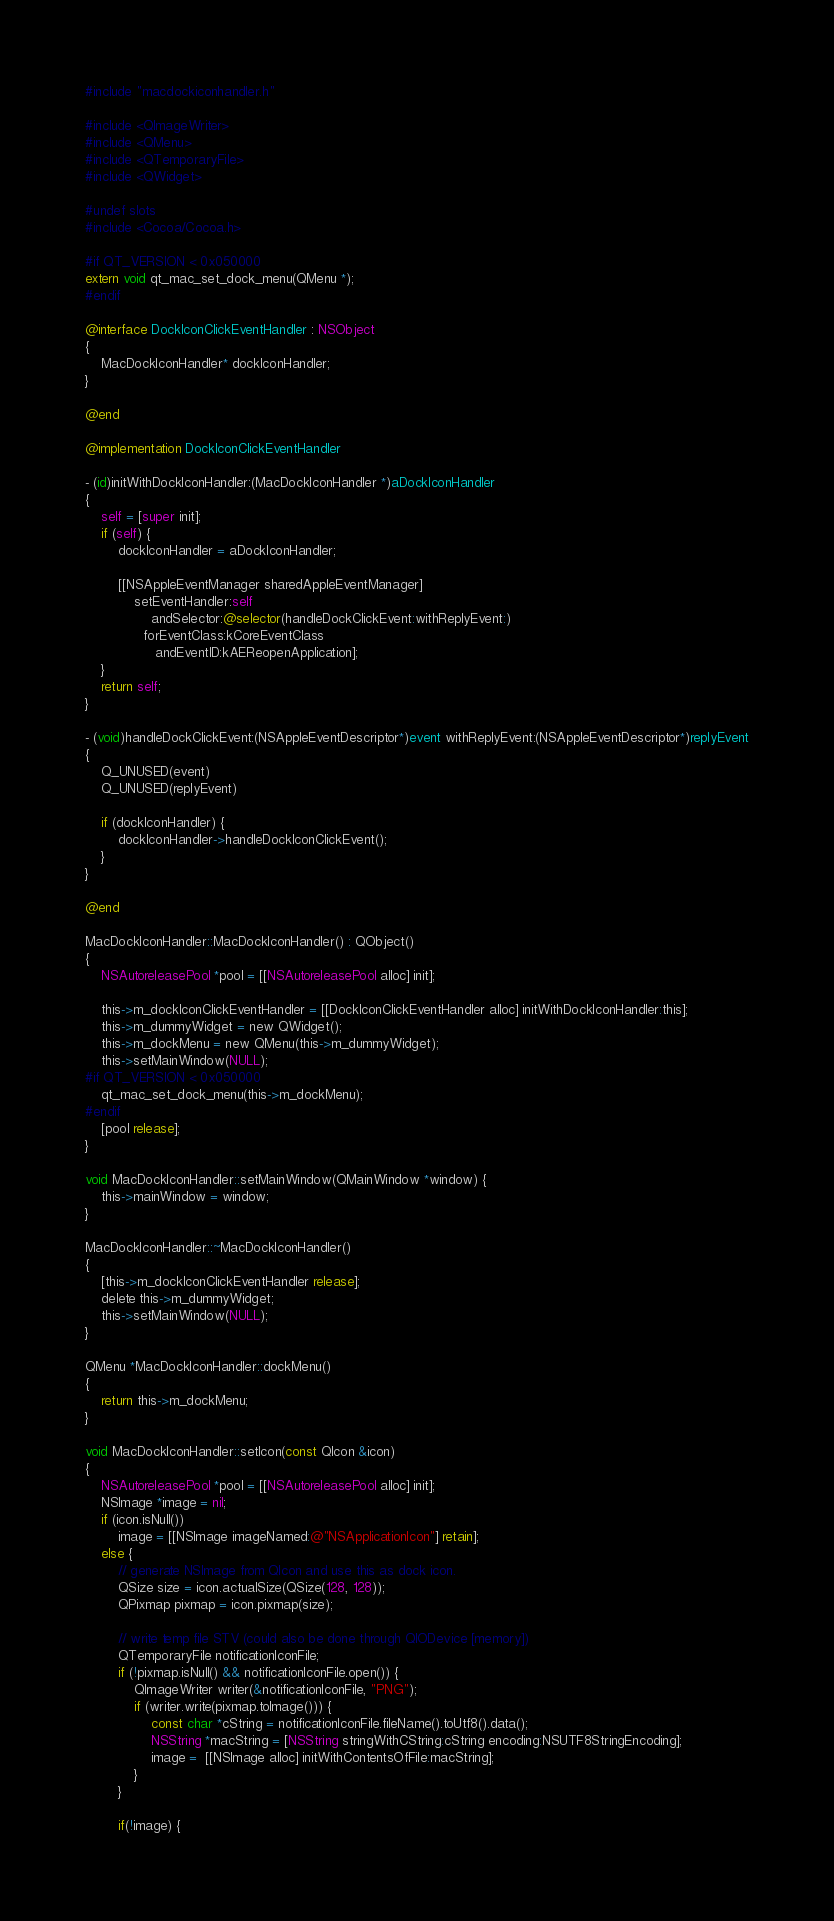Convert code to text. <code><loc_0><loc_0><loc_500><loc_500><_ObjectiveC_>#include "macdockiconhandler.h"

#include <QImageWriter>
#include <QMenu>
#include <QTemporaryFile>
#include <QWidget>

#undef slots
#include <Cocoa/Cocoa.h>

#if QT_VERSION < 0x050000
extern void qt_mac_set_dock_menu(QMenu *);
#endif

@interface DockIconClickEventHandler : NSObject
{
    MacDockIconHandler* dockIconHandler;
}

@end

@implementation DockIconClickEventHandler

- (id)initWithDockIconHandler:(MacDockIconHandler *)aDockIconHandler
{
    self = [super init];
    if (self) {
        dockIconHandler = aDockIconHandler;

        [[NSAppleEventManager sharedAppleEventManager]
            setEventHandler:self
                andSelector:@selector(handleDockClickEvent:withReplyEvent:)
              forEventClass:kCoreEventClass
                 andEventID:kAEReopenApplication];
    }
    return self;
}

- (void)handleDockClickEvent:(NSAppleEventDescriptor*)event withReplyEvent:(NSAppleEventDescriptor*)replyEvent
{
    Q_UNUSED(event)
    Q_UNUSED(replyEvent)

    if (dockIconHandler) {
        dockIconHandler->handleDockIconClickEvent();
    }
}

@end

MacDockIconHandler::MacDockIconHandler() : QObject()
{
    NSAutoreleasePool *pool = [[NSAutoreleasePool alloc] init];

    this->m_dockIconClickEventHandler = [[DockIconClickEventHandler alloc] initWithDockIconHandler:this];
    this->m_dummyWidget = new QWidget();
    this->m_dockMenu = new QMenu(this->m_dummyWidget);
    this->setMainWindow(NULL);
#if QT_VERSION < 0x050000
    qt_mac_set_dock_menu(this->m_dockMenu);
#endif
    [pool release];
}

void MacDockIconHandler::setMainWindow(QMainWindow *window) {
    this->mainWindow = window;
}

MacDockIconHandler::~MacDockIconHandler()
{
    [this->m_dockIconClickEventHandler release];
    delete this->m_dummyWidget;
    this->setMainWindow(NULL);
}

QMenu *MacDockIconHandler::dockMenu()
{
    return this->m_dockMenu;
}

void MacDockIconHandler::setIcon(const QIcon &icon)
{
    NSAutoreleasePool *pool = [[NSAutoreleasePool alloc] init];
    NSImage *image = nil;
    if (icon.isNull())
        image = [[NSImage imageNamed:@"NSApplicationIcon"] retain];
    else {
        // generate NSImage from QIcon and use this as dock icon.
        QSize size = icon.actualSize(QSize(128, 128));
        QPixmap pixmap = icon.pixmap(size);

        // write temp file STV (could also be done through QIODevice [memory])
        QTemporaryFile notificationIconFile;
        if (!pixmap.isNull() && notificationIconFile.open()) {
            QImageWriter writer(&notificationIconFile, "PNG");
            if (writer.write(pixmap.toImage())) {
                const char *cString = notificationIconFile.fileName().toUtf8().data();
                NSString *macString = [NSString stringWithCString:cString encoding:NSUTF8StringEncoding];
                image =  [[NSImage alloc] initWithContentsOfFile:macString];
            }
        }

        if(!image) {</code> 